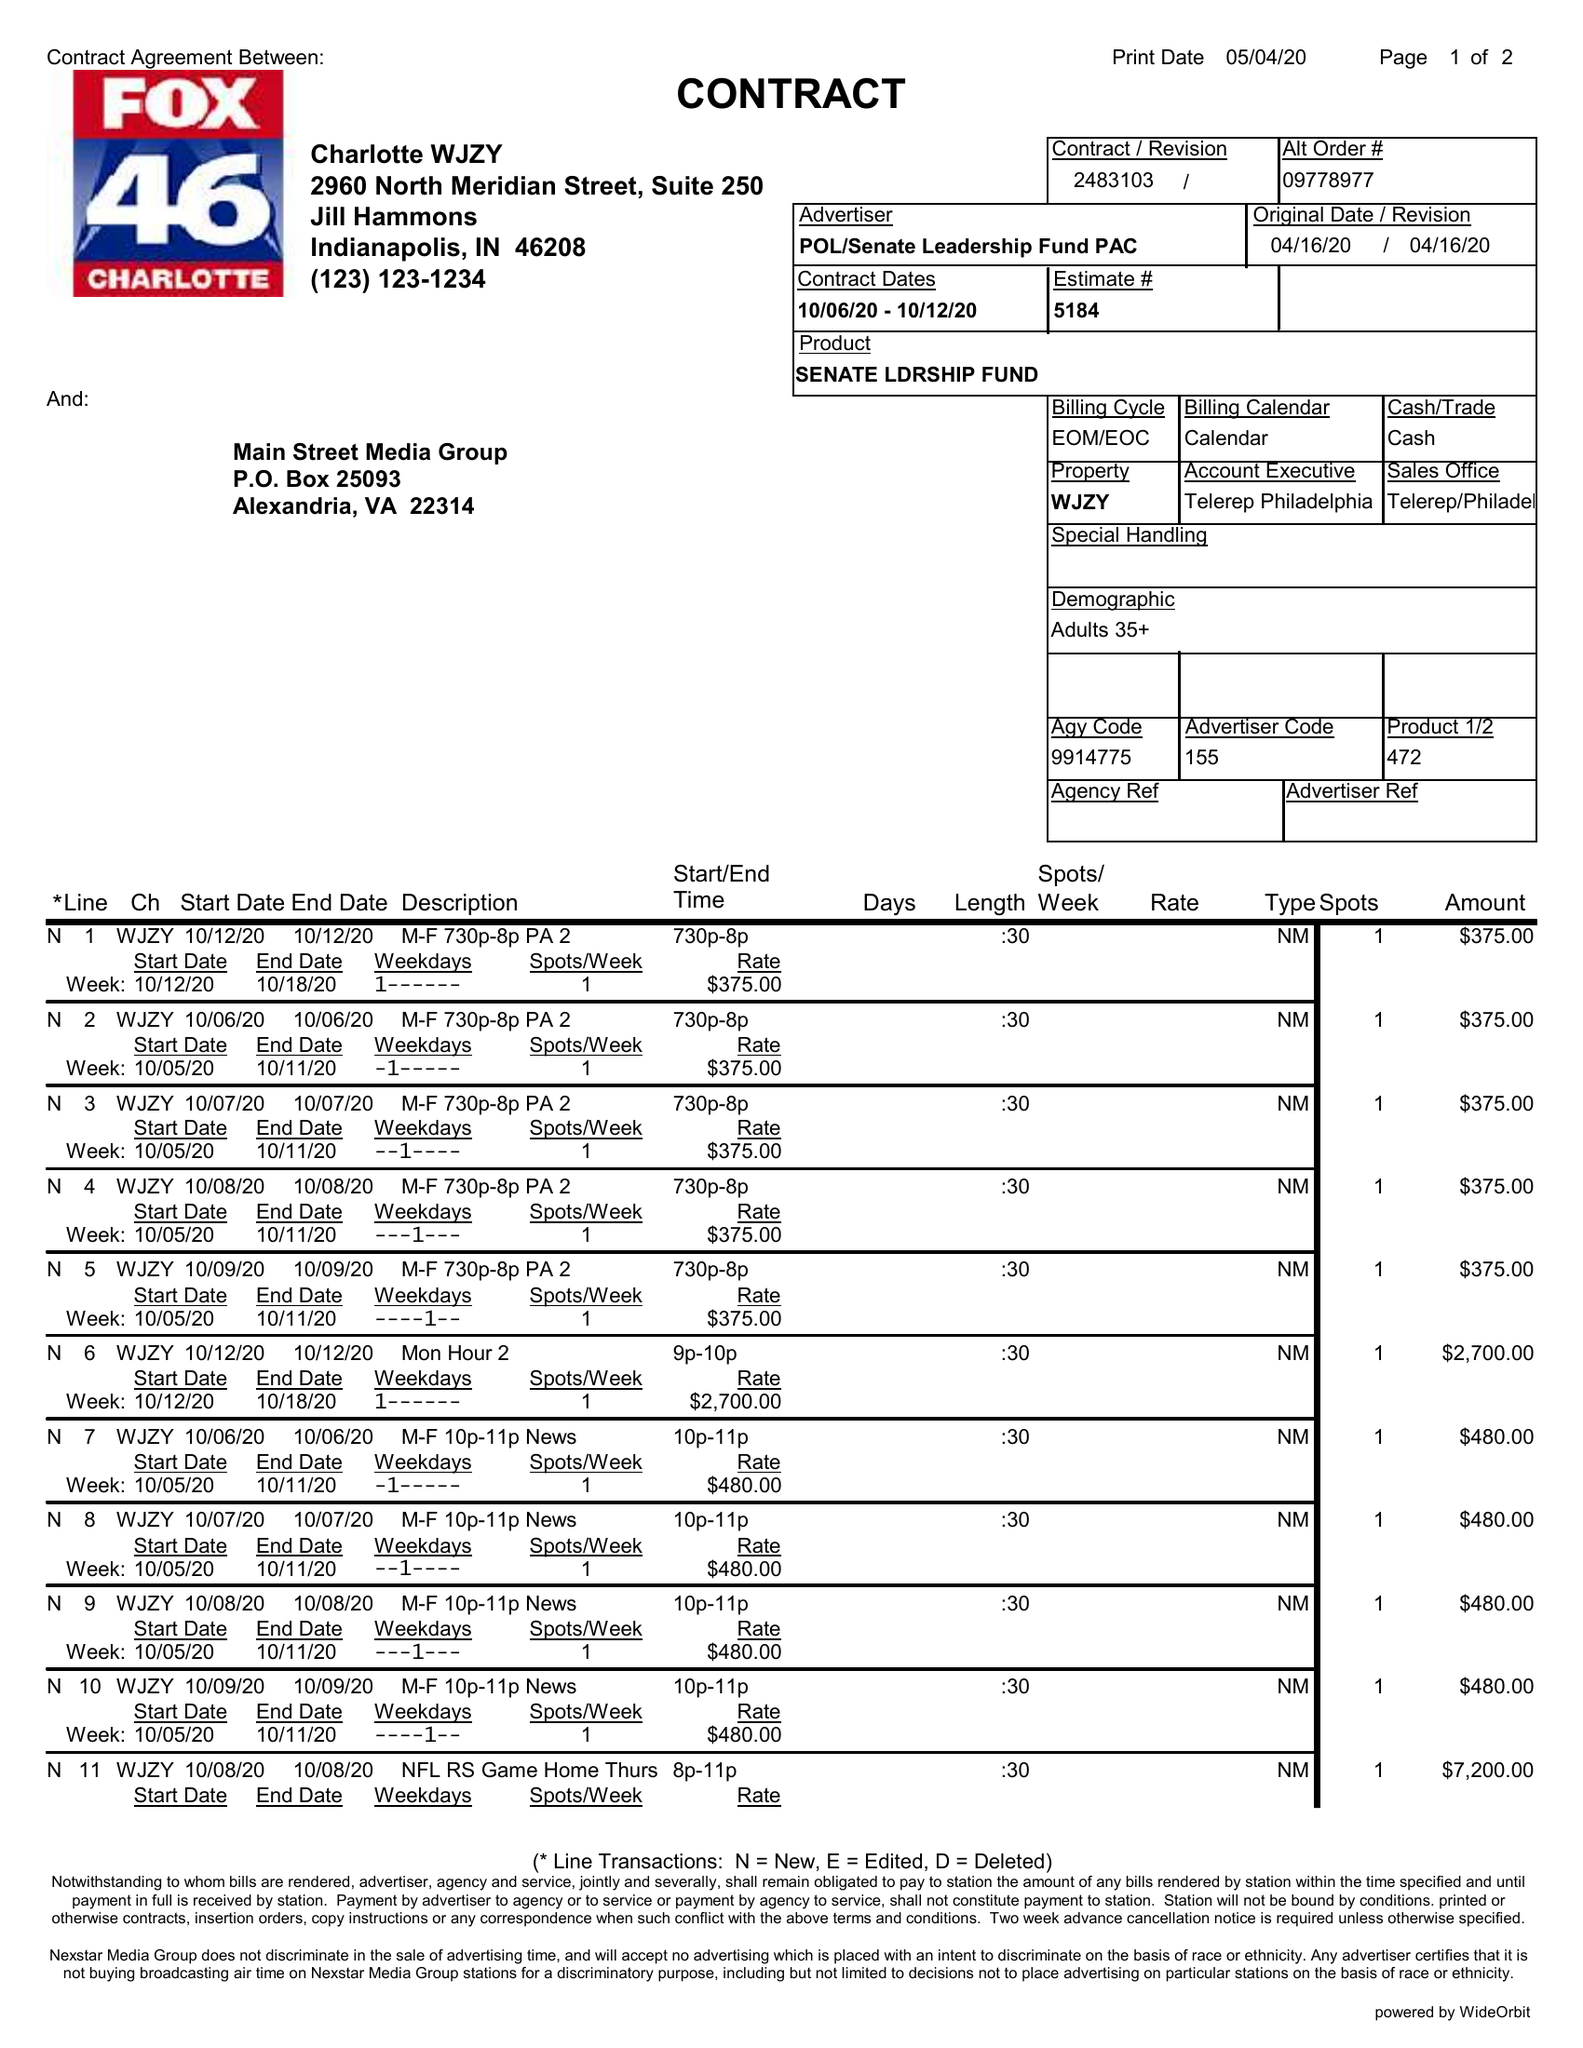What is the value for the advertiser?
Answer the question using a single word or phrase. POL/SENATELEADERSHIPFUNDPAC 